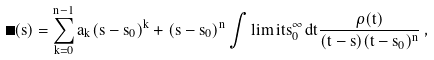<formula> <loc_0><loc_0><loc_500><loc_500>\Pi ( s ) = \sum _ { k = 0 } ^ { n - 1 } a _ { k } ( s - s _ { 0 } ) ^ { k } + ( s - s _ { 0 } ) ^ { n } \int \lim i t s _ { 0 } ^ { \infty } \, d t \frac { \rho ( t ) } { ( t - s ) ( t - s _ { 0 } ) ^ { n } } \, ,</formula> 